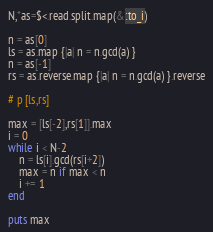<code> <loc_0><loc_0><loc_500><loc_500><_Ruby_>N,*as=$<.read.split.map(&:to_i)

n = as[0]
ls = as.map {|a| n = n.gcd(a) }
n = as[-1]
rs = as.reverse.map {|a| n = n.gcd(a) }.reverse

# p [ls,rs]

max = [ls[-2],rs[1]].max
i = 0
while i < N-2
    n = ls[i].gcd(rs[i+2])
    max = n if max < n
    i += 1
end

puts max</code> 